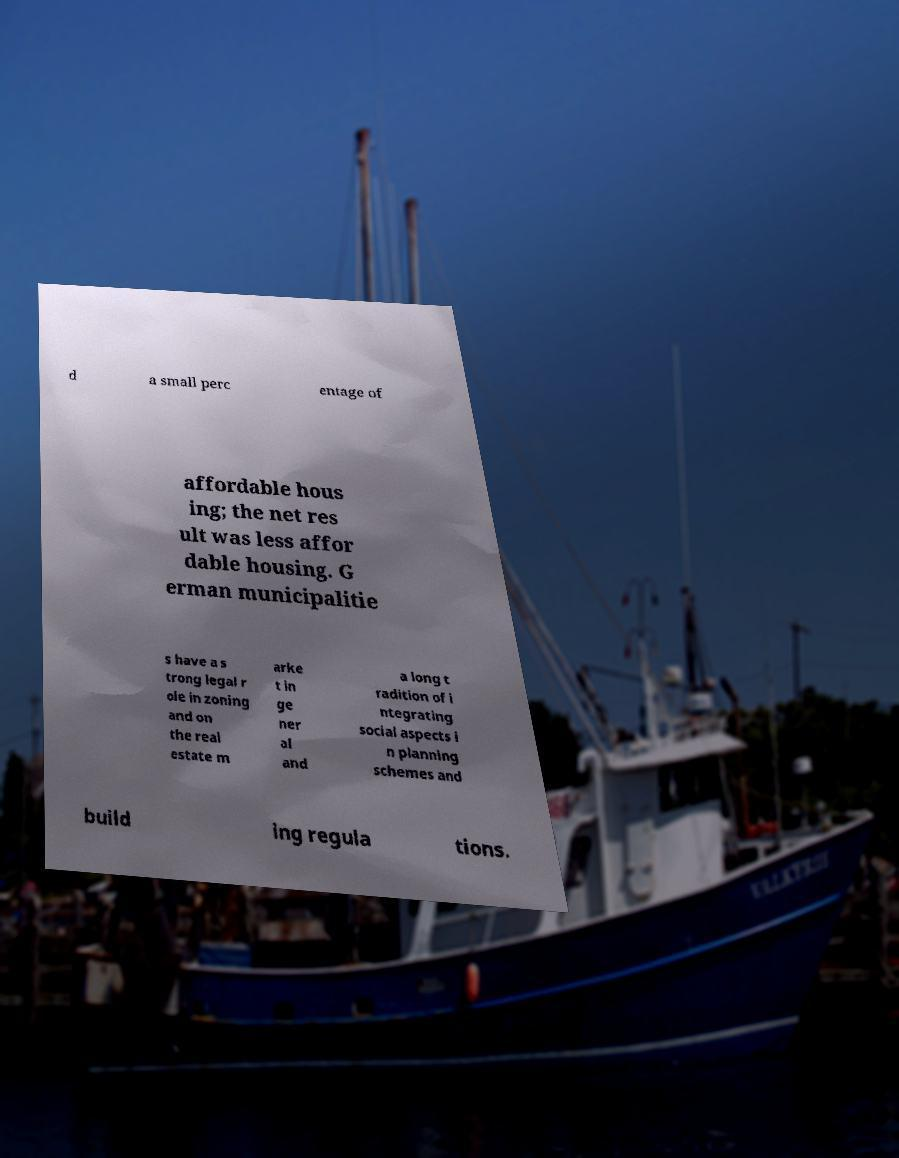Could you extract and type out the text from this image? d a small perc entage of affordable hous ing; the net res ult was less affor dable housing. G erman municipalitie s have a s trong legal r ole in zoning and on the real estate m arke t in ge ner al and a long t radition of i ntegrating social aspects i n planning schemes and build ing regula tions. 